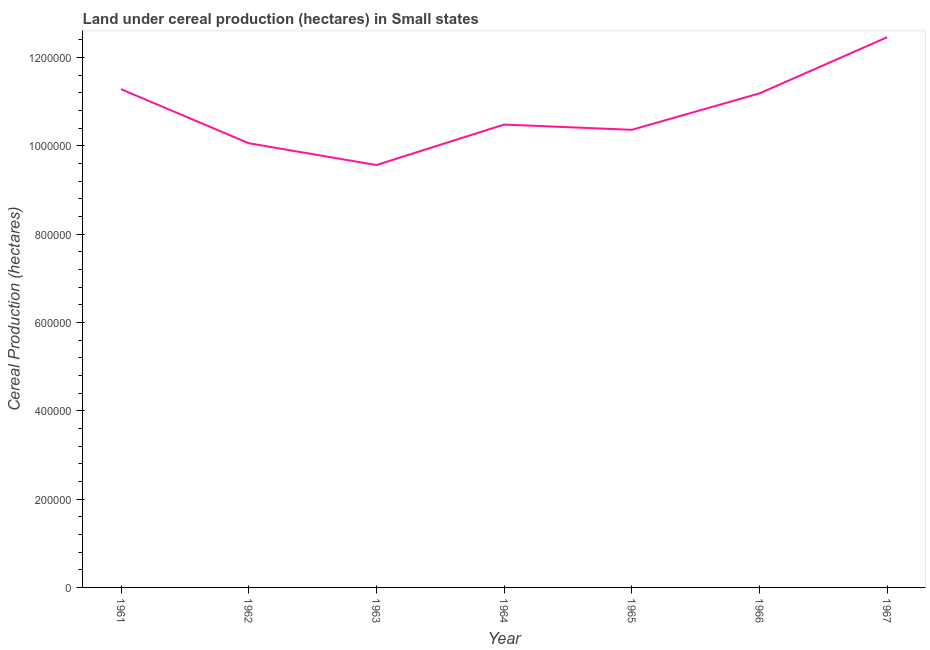What is the land under cereal production in 1961?
Your answer should be compact. 1.13e+06. Across all years, what is the maximum land under cereal production?
Make the answer very short. 1.25e+06. Across all years, what is the minimum land under cereal production?
Offer a very short reply. 9.56e+05. In which year was the land under cereal production maximum?
Keep it short and to the point. 1967. In which year was the land under cereal production minimum?
Your response must be concise. 1963. What is the sum of the land under cereal production?
Your answer should be very brief. 7.54e+06. What is the difference between the land under cereal production in 1964 and 1967?
Give a very brief answer. -1.98e+05. What is the average land under cereal production per year?
Your answer should be compact. 1.08e+06. What is the median land under cereal production?
Offer a very short reply. 1.05e+06. In how many years, is the land under cereal production greater than 520000 hectares?
Offer a terse response. 7. Do a majority of the years between 1966 and 1962 (inclusive) have land under cereal production greater than 800000 hectares?
Make the answer very short. Yes. What is the ratio of the land under cereal production in 1963 to that in 1964?
Your response must be concise. 0.91. Is the land under cereal production in 1963 less than that in 1966?
Your response must be concise. Yes. Is the difference between the land under cereal production in 1961 and 1964 greater than the difference between any two years?
Offer a very short reply. No. What is the difference between the highest and the second highest land under cereal production?
Ensure brevity in your answer.  1.18e+05. What is the difference between the highest and the lowest land under cereal production?
Keep it short and to the point. 2.89e+05. In how many years, is the land under cereal production greater than the average land under cereal production taken over all years?
Ensure brevity in your answer.  3. Does the land under cereal production monotonically increase over the years?
Offer a terse response. No. How many lines are there?
Your answer should be very brief. 1. How many years are there in the graph?
Offer a terse response. 7. What is the difference between two consecutive major ticks on the Y-axis?
Provide a short and direct response. 2.00e+05. Are the values on the major ticks of Y-axis written in scientific E-notation?
Offer a terse response. No. Does the graph contain any zero values?
Provide a short and direct response. No. What is the title of the graph?
Your answer should be very brief. Land under cereal production (hectares) in Small states. What is the label or title of the Y-axis?
Provide a short and direct response. Cereal Production (hectares). What is the Cereal Production (hectares) in 1961?
Offer a terse response. 1.13e+06. What is the Cereal Production (hectares) in 1962?
Make the answer very short. 1.01e+06. What is the Cereal Production (hectares) in 1963?
Ensure brevity in your answer.  9.56e+05. What is the Cereal Production (hectares) in 1964?
Your answer should be very brief. 1.05e+06. What is the Cereal Production (hectares) in 1965?
Your answer should be compact. 1.04e+06. What is the Cereal Production (hectares) of 1966?
Make the answer very short. 1.12e+06. What is the Cereal Production (hectares) of 1967?
Offer a terse response. 1.25e+06. What is the difference between the Cereal Production (hectares) in 1961 and 1962?
Give a very brief answer. 1.22e+05. What is the difference between the Cereal Production (hectares) in 1961 and 1963?
Provide a succinct answer. 1.72e+05. What is the difference between the Cereal Production (hectares) in 1961 and 1964?
Your answer should be very brief. 8.01e+04. What is the difference between the Cereal Production (hectares) in 1961 and 1965?
Offer a terse response. 9.19e+04. What is the difference between the Cereal Production (hectares) in 1961 and 1966?
Make the answer very short. 9478. What is the difference between the Cereal Production (hectares) in 1961 and 1967?
Give a very brief answer. -1.18e+05. What is the difference between the Cereal Production (hectares) in 1962 and 1963?
Make the answer very short. 4.94e+04. What is the difference between the Cereal Production (hectares) in 1962 and 1964?
Your response must be concise. -4.22e+04. What is the difference between the Cereal Production (hectares) in 1962 and 1965?
Provide a succinct answer. -3.04e+04. What is the difference between the Cereal Production (hectares) in 1962 and 1966?
Ensure brevity in your answer.  -1.13e+05. What is the difference between the Cereal Production (hectares) in 1962 and 1967?
Offer a terse response. -2.40e+05. What is the difference between the Cereal Production (hectares) in 1963 and 1964?
Your response must be concise. -9.16e+04. What is the difference between the Cereal Production (hectares) in 1963 and 1965?
Give a very brief answer. -7.98e+04. What is the difference between the Cereal Production (hectares) in 1963 and 1966?
Give a very brief answer. -1.62e+05. What is the difference between the Cereal Production (hectares) in 1963 and 1967?
Provide a short and direct response. -2.89e+05. What is the difference between the Cereal Production (hectares) in 1964 and 1965?
Offer a terse response. 1.19e+04. What is the difference between the Cereal Production (hectares) in 1964 and 1966?
Your response must be concise. -7.06e+04. What is the difference between the Cereal Production (hectares) in 1964 and 1967?
Your response must be concise. -1.98e+05. What is the difference between the Cereal Production (hectares) in 1965 and 1966?
Ensure brevity in your answer.  -8.25e+04. What is the difference between the Cereal Production (hectares) in 1965 and 1967?
Your answer should be compact. -2.10e+05. What is the difference between the Cereal Production (hectares) in 1966 and 1967?
Give a very brief answer. -1.27e+05. What is the ratio of the Cereal Production (hectares) in 1961 to that in 1962?
Offer a terse response. 1.12. What is the ratio of the Cereal Production (hectares) in 1961 to that in 1963?
Your answer should be compact. 1.18. What is the ratio of the Cereal Production (hectares) in 1961 to that in 1964?
Your answer should be compact. 1.08. What is the ratio of the Cereal Production (hectares) in 1961 to that in 1965?
Give a very brief answer. 1.09. What is the ratio of the Cereal Production (hectares) in 1961 to that in 1966?
Provide a succinct answer. 1.01. What is the ratio of the Cereal Production (hectares) in 1961 to that in 1967?
Provide a short and direct response. 0.91. What is the ratio of the Cereal Production (hectares) in 1962 to that in 1963?
Your answer should be very brief. 1.05. What is the ratio of the Cereal Production (hectares) in 1962 to that in 1966?
Offer a terse response. 0.9. What is the ratio of the Cereal Production (hectares) in 1962 to that in 1967?
Offer a terse response. 0.81. What is the ratio of the Cereal Production (hectares) in 1963 to that in 1965?
Your answer should be very brief. 0.92. What is the ratio of the Cereal Production (hectares) in 1963 to that in 1966?
Offer a very short reply. 0.85. What is the ratio of the Cereal Production (hectares) in 1963 to that in 1967?
Your answer should be compact. 0.77. What is the ratio of the Cereal Production (hectares) in 1964 to that in 1965?
Your response must be concise. 1.01. What is the ratio of the Cereal Production (hectares) in 1964 to that in 1966?
Make the answer very short. 0.94. What is the ratio of the Cereal Production (hectares) in 1964 to that in 1967?
Your answer should be compact. 0.84. What is the ratio of the Cereal Production (hectares) in 1965 to that in 1966?
Offer a very short reply. 0.93. What is the ratio of the Cereal Production (hectares) in 1965 to that in 1967?
Offer a terse response. 0.83. What is the ratio of the Cereal Production (hectares) in 1966 to that in 1967?
Your answer should be compact. 0.9. 